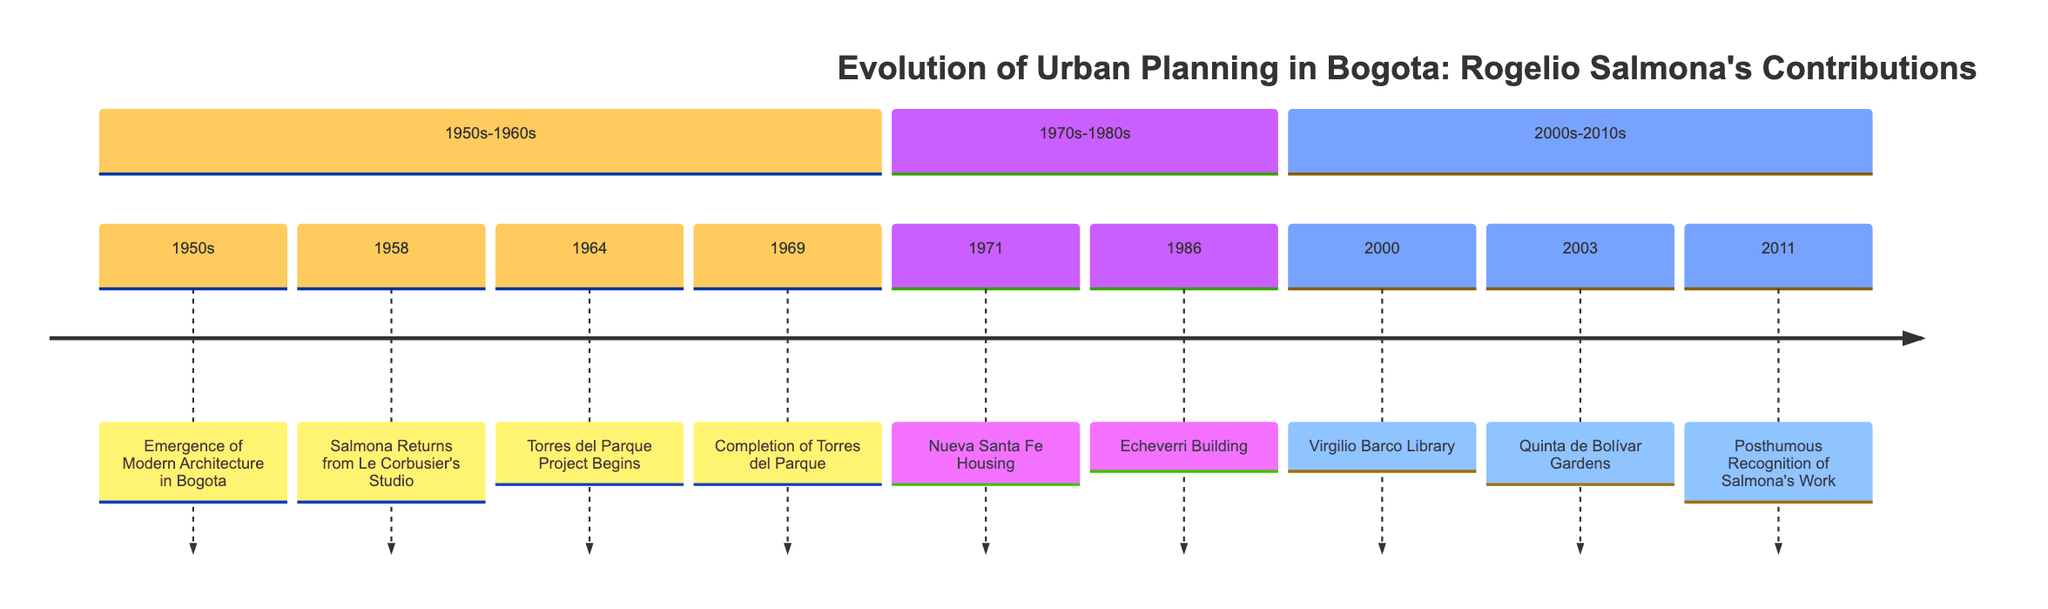What decade did Salmona return from Le Corbusier's studio? The timeline indicates that Salmona returned from Le Corbusier's studio in 1958, which is noted in the section for the 1950s-1960s.
Answer: 1950s-1960s What significant project was completed in 1969? Referring to the timeline, it shows that the Torres del Parque project was completed in 1969 in the same section.
Answer: Torres del Parque How many projects are listed in the 1970s-1980s section? To determine this, we look at the timeline and count the projects under the 1970s-1980s section, which lists two: Nueva Santa Fe Housing in 1971 and Echeverri Building in 1986.
Answer: 2 Which project received posthumous recognition in 2011? The timeline notes that in 2011 there was posthumous recognition for Salmona's work, as stated in the section for the 2000s-2010s.
Answer: Salmona's work What year marks the beginning of the Torres del Parque project? The diagram specifies that the Torres del Parque project began in 1964, as indicated in the section for the 1950s-1960s.
Answer: 1964 In which section is the Virgilio Barco Library listed? The timeline shows the Virgilio Barco Library located in the section for the 2000s-2010s, confirming its placement.
Answer: 2000s-2010s How many total entries are there across all sections? Adding all the entries: 4 from the 1950s-1960s, 2 from the 1970s-1980s, and 3 from the 2000s-2010s gives us a total of 9.
Answer: 9 Which project is the first listed in the diagram? Starting from the earliest entry, the timeline reveals that the first listed project is the Emergence of Modern Architecture in Bogota in the 1950s.
Answer: Emergence of Modern Architecture in Bogota What is the primary color used in the timeline's theme? The diagram defines the primary color for the theme as a specific shade of yellow, represented by the hex code provided in the styling section.
Answer: #f0e68c 